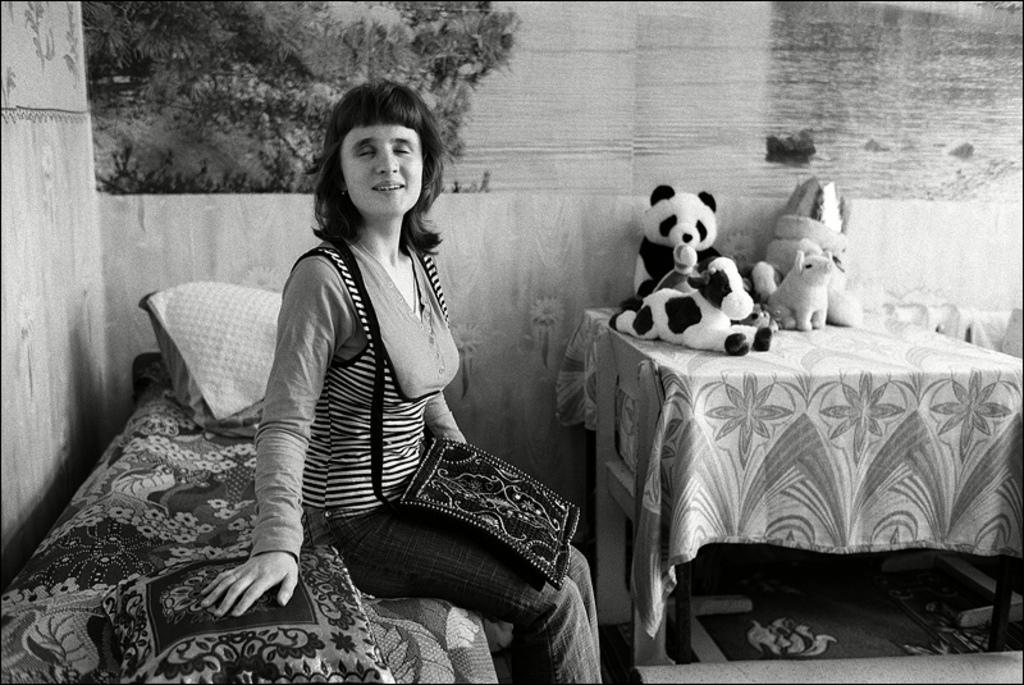How would you summarize this image in a sentence or two? It is a black and white image there is a woman sitting on the bed, she is closing her eyes ,she is wearing a back beside her there is a table on the table there are few toys ,in the background there is a wall and also a poster on the wall. 